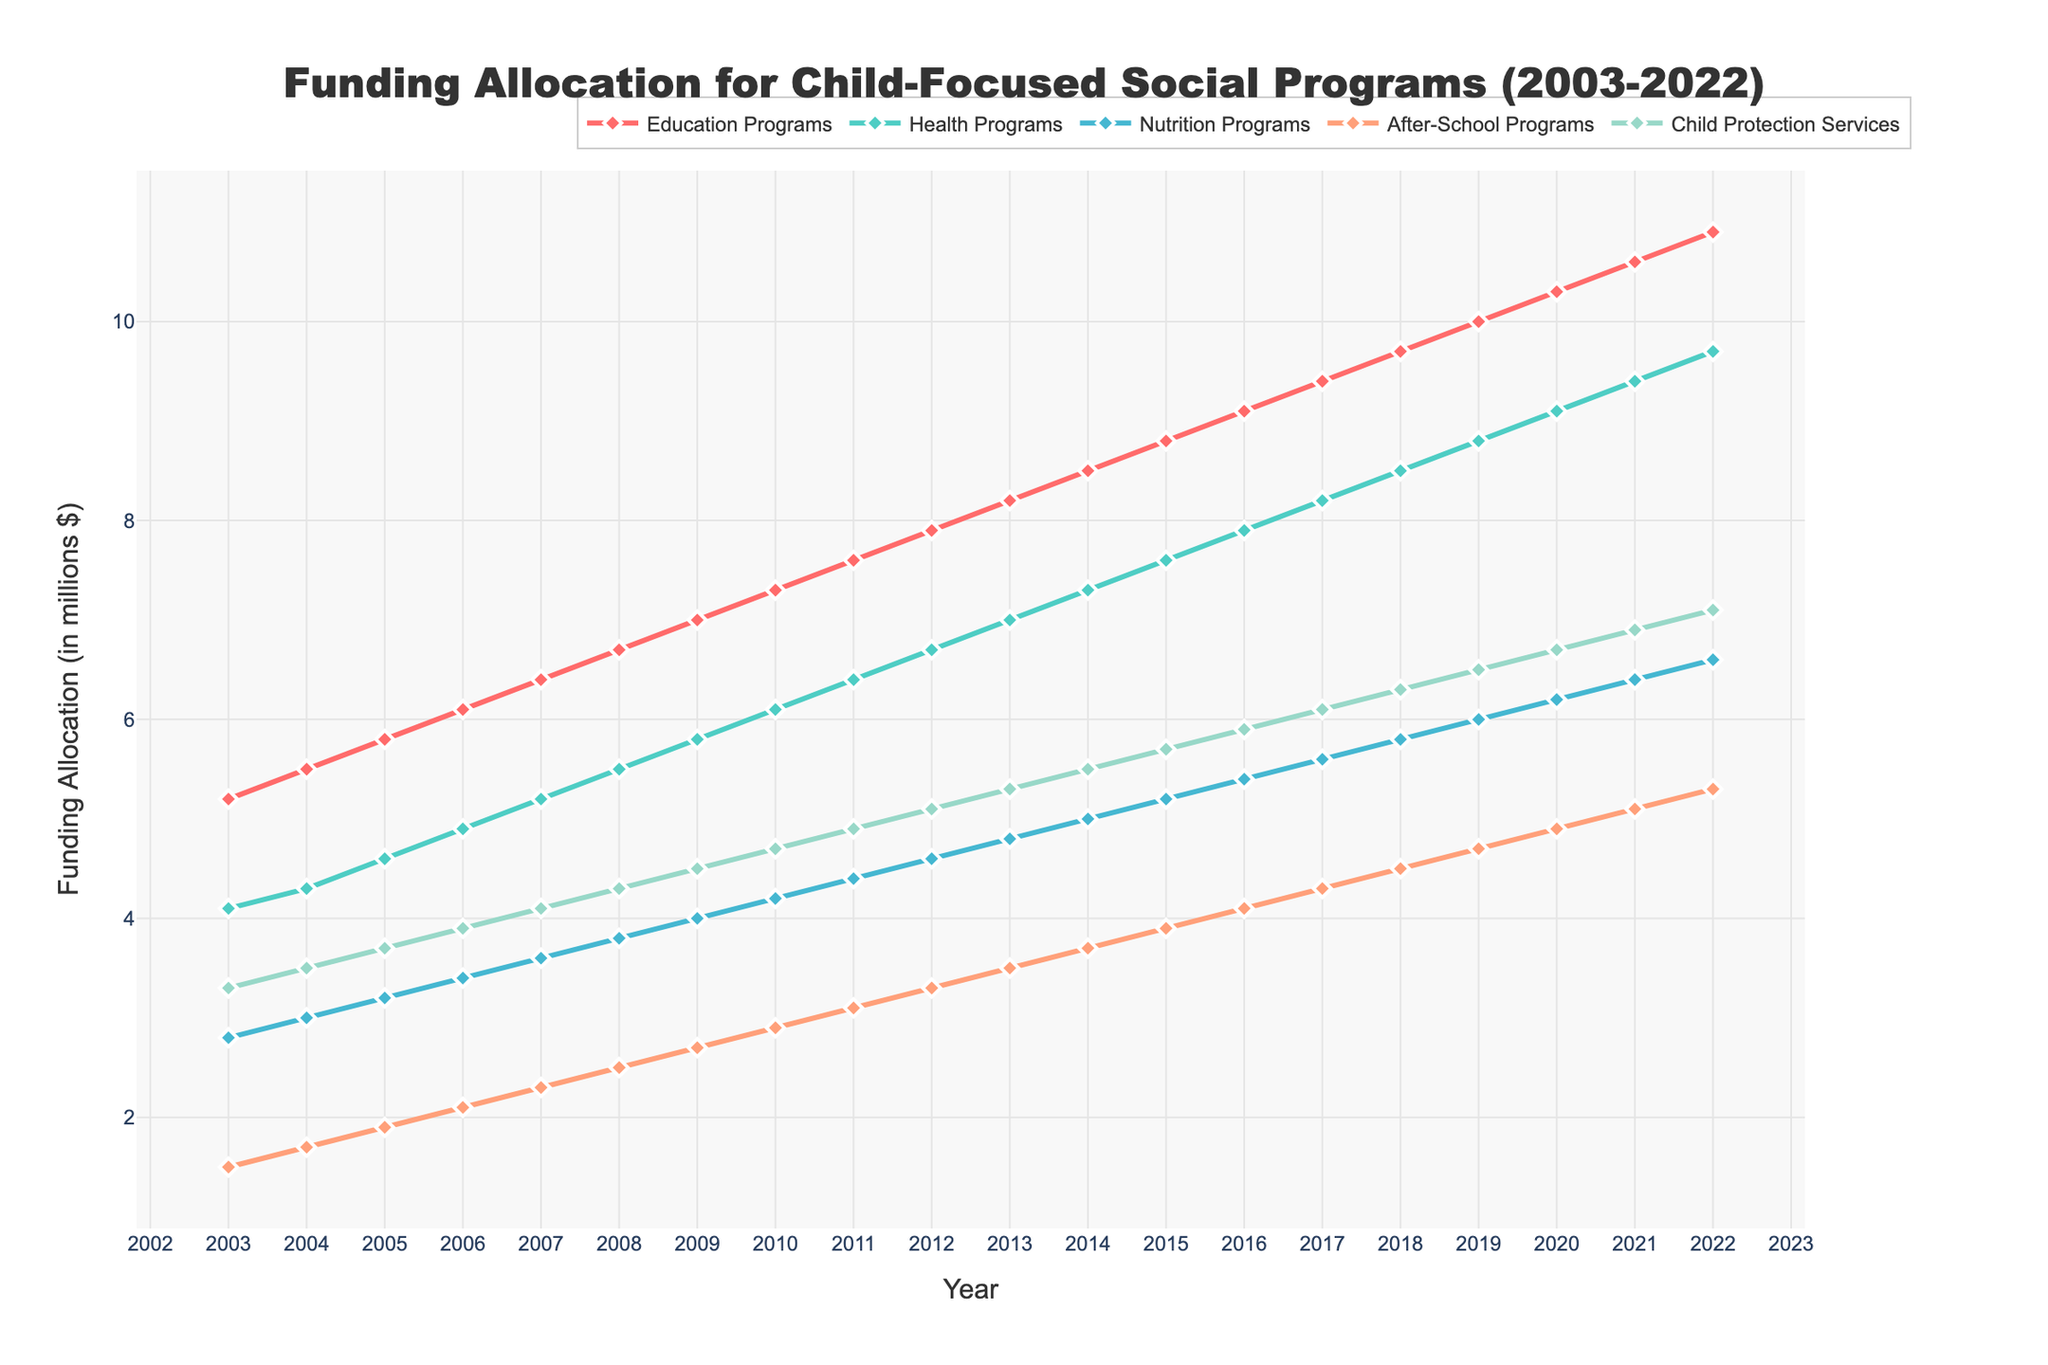Which program had the highest funding allocation in 2022? According to the figure, the green line representing Education Programs reaches the highest point in 2022 compared to other lines.
Answer: Education Programs How much did the funding allocation for Health Programs increase from 2003 to 2022? In 2003, the funding for Health Programs was 4.1 million dollars, and in 2022, it was 9.7 million dollars. The increase is 9.7 - 4.1 = 5.6 million dollars.
Answer: 5.6 million dollars Which year's allocation for Nutrition Programs was equal to the allocation for After-School Programs in 2016? By examining the lines for Nutrition Programs and After-School Programs, in 2016, After-School Programs had a funding of 4.1 million dollars. In the same year, Nutrition Programs also had an allocation of 5.4 million dollars, so we are looking for an earlier year. In 2003, After-School Programs had funding close to 1.5 million dollars, which was not matched by Nutrition Programs for any year. Therefore, no such year exists.
Answer: No such year exists Compare the trend of Child Protection Services funding with that of Education Programs over the two decades. The trend for Education Programs (the green line) shows a steady increase from 5.2 million dollars in 2003 to 10.9 million dollars in 2022. Child Protection Services (the blue line) also shows an increase but at a slower rate, from 3.3 million dollars in 2003 to 7.1 million dollars in 2022.
Answer: Both increased, Education Programs at a faster pace What is the combined funding allocation for Education Programs and Health Programs in 2020? In 2020, the funding for Education Programs was 10.3 million dollars, and for Health Programs, it was 9.1 million dollars. Combined, it is 10.3 + 9.1 = 19.4 million dollars.
Answer: 19.4 million dollars Which two programs have the closest funding allocation in 2007? In 2007, the funding allocations are: Education (6.4), Health (5.2), Nutrition (3.6), After-School (2.3), Child Protection (4.1). By comparing the values, Health Programs and Child Protection Services are the closest with 5.2 million and 4.1 million dollars, respectively.
Answer: Health Programs and Child Protection Services What is the average annual increase in funding for Education Programs over the two decades? In 2003, the funding was 5.2 million dollars, and in 2022, it was 10.9 million dollars. The increase over the two decades is 10.9 - 5.2 = 5.7 million dollars. There are 19 years between 2003 and 2022, so the average annual increase is 5.7 / 19 ≈ 0.3 million dollars per year.
Answer: 0.3 million dollars per year Rank the programs in terms of their funding growth rate from 2003 to 2022. Calculating the increase for each program:
- Education: 10.9 - 5.2 = 5.7
- Health: 9.7 - 4.1 = 5.6
- Nutrition: 6.6 - 2.8 = 3.8
- After-School: 5.3 - 1.5 = 3.8
- Child Protection: 7.1 - 3.3 = 3.8
The ranking is based on the raw increases in funding:
1. Education (5.7)
2. Health (5.6)
3. Nutrition, After-School, Child Protection (3.8 each)
Answer: Education, Health, Nutrition / After-School / Child Protection In which year did After-School Programs experience the steepest year-over-year increase? By examining the line for After-School Programs, the year-over-year increases are more obvious between 2010 and 2011, and 2021 and 2022; the increase from 2020 to 2021 was 0.2 million dollars, and from 2021 to 2022 also was 0.2. Hence, the steepest increase occurred between 2010 and 2011.
Answer: 2010 to 2011 